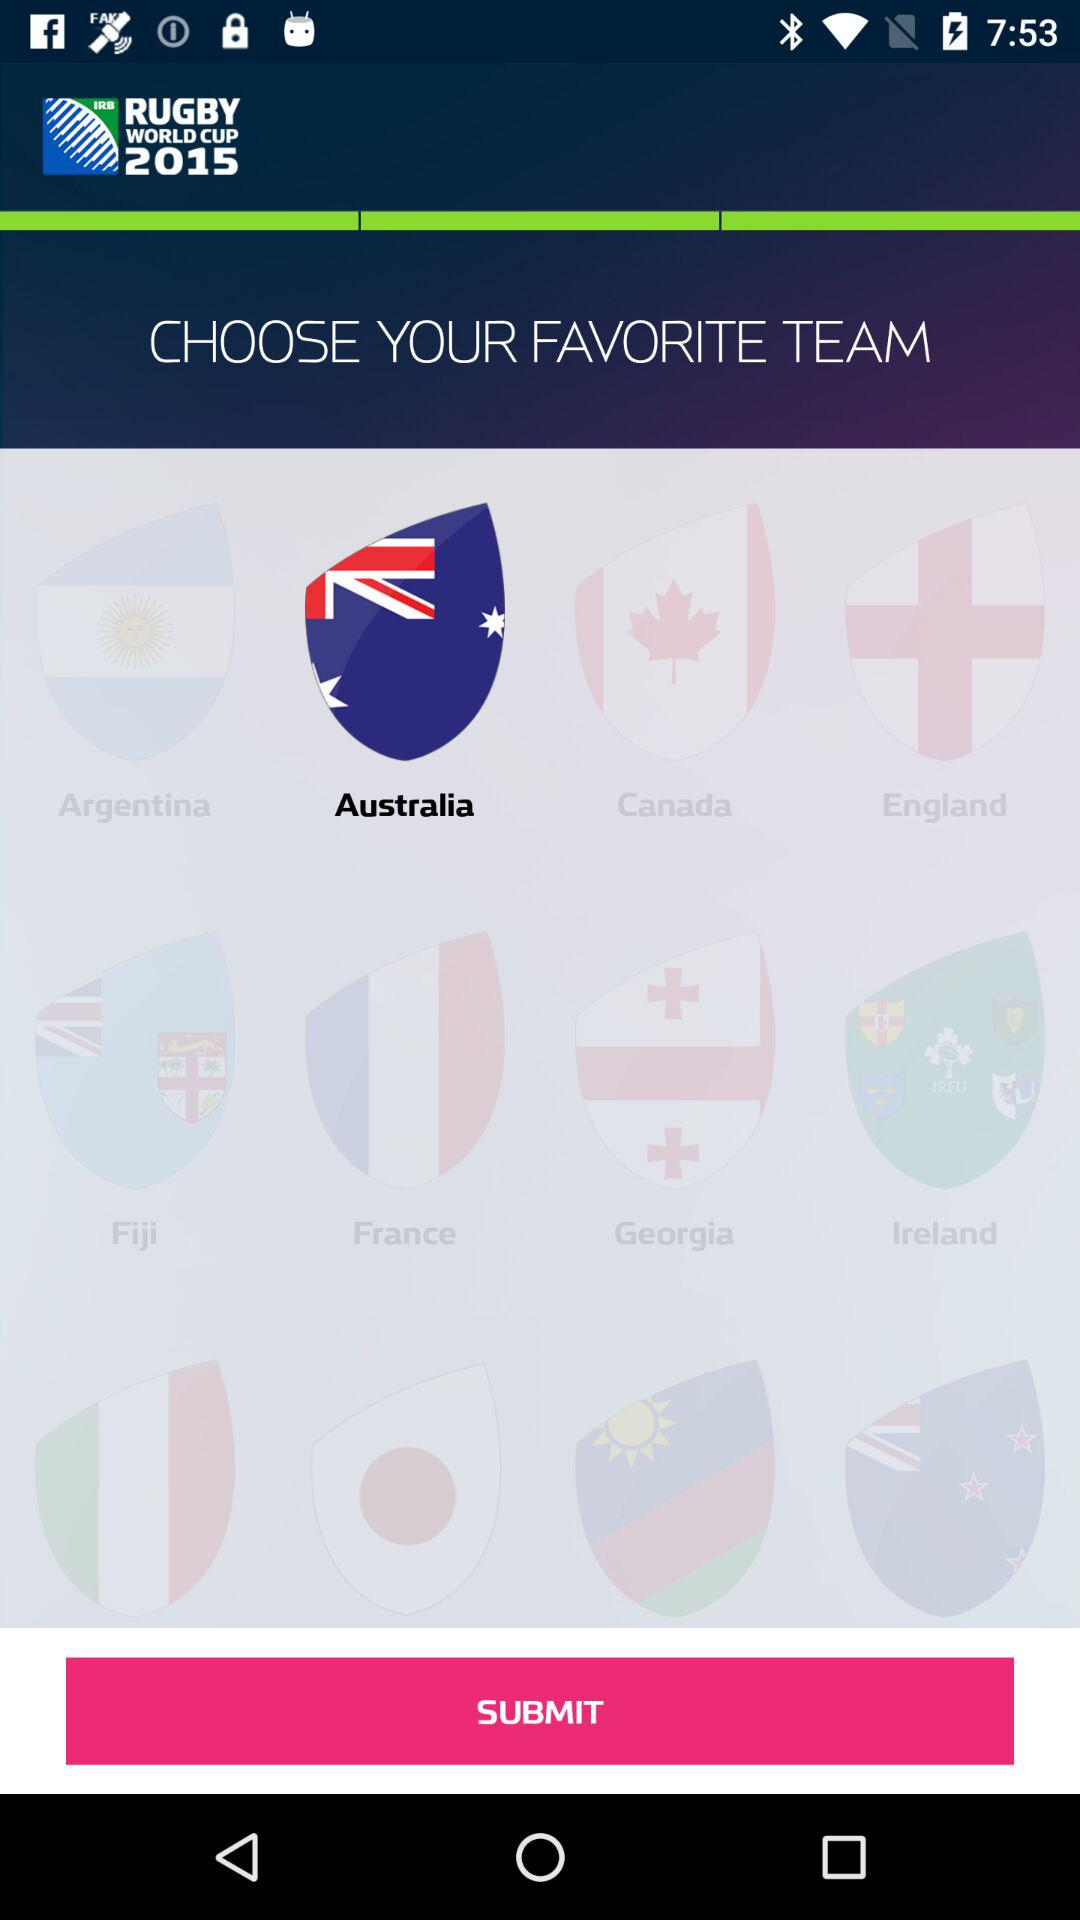Which team has been selected? The selected team is "Australia". 